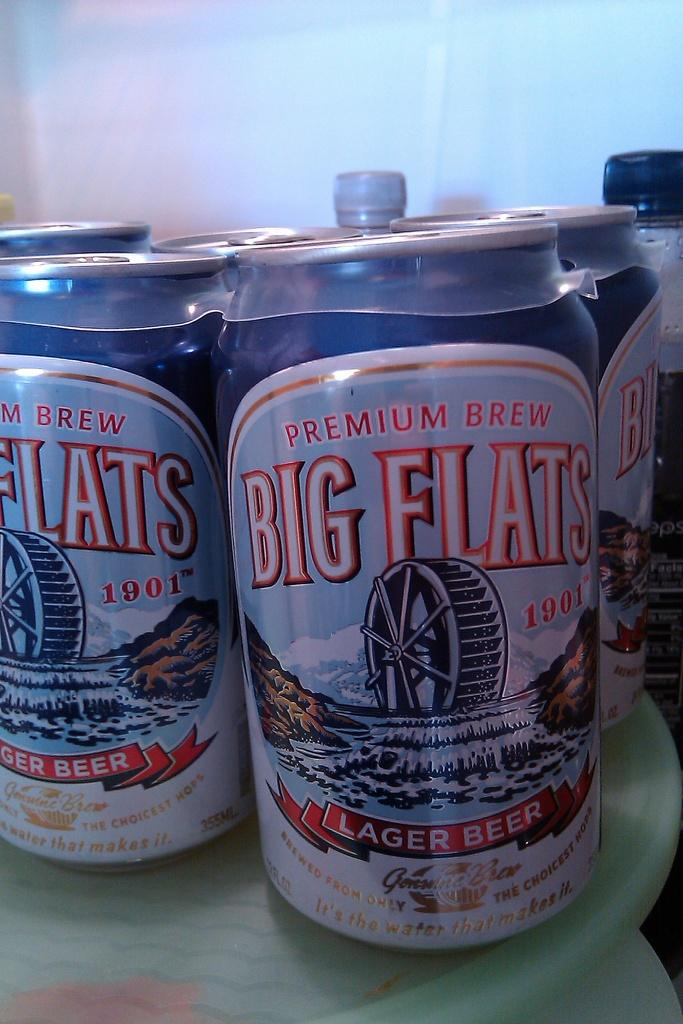<image>
Write a terse but informative summary of the picture. Several cans of Big Flats premium lager beer/ 